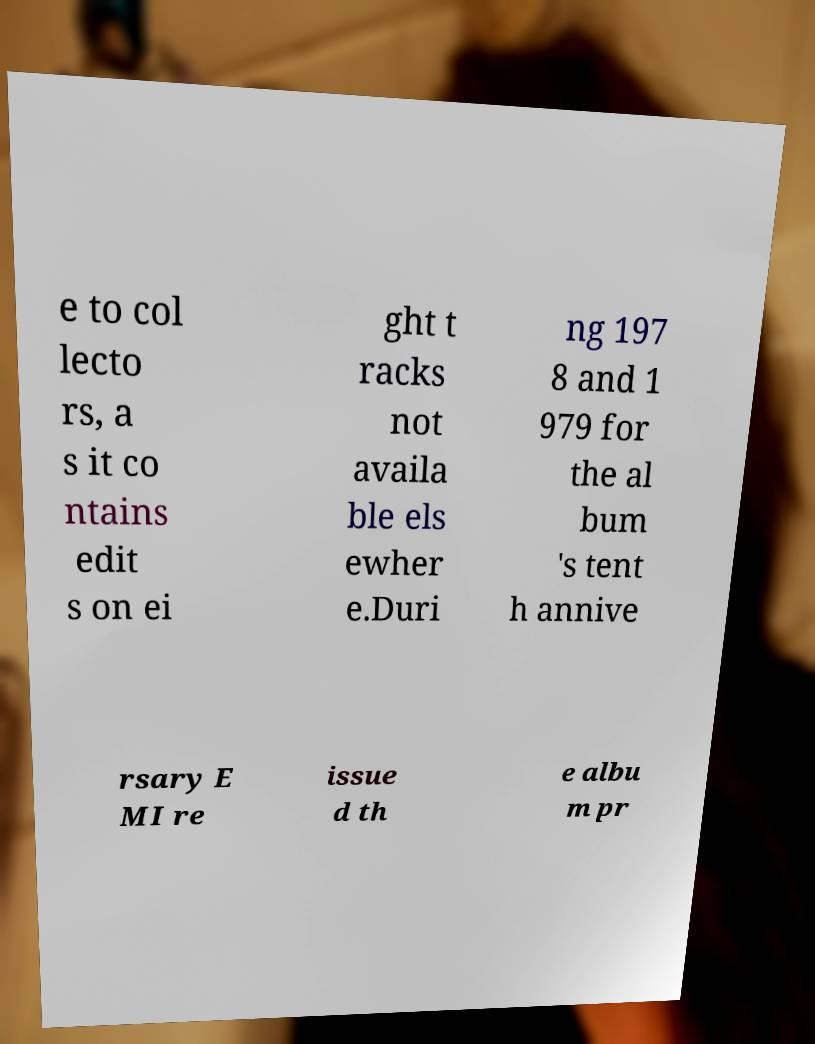What messages or text are displayed in this image? I need them in a readable, typed format. e to col lecto rs, a s it co ntains edit s on ei ght t racks not availa ble els ewher e.Duri ng 197 8 and 1 979 for the al bum 's tent h annive rsary E MI re issue d th e albu m pr 